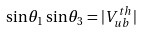Convert formula to latex. <formula><loc_0><loc_0><loc_500><loc_500>\sin \theta _ { 1 } \sin \theta _ { 3 } = | { V } _ { u b } ^ { t h } |</formula> 